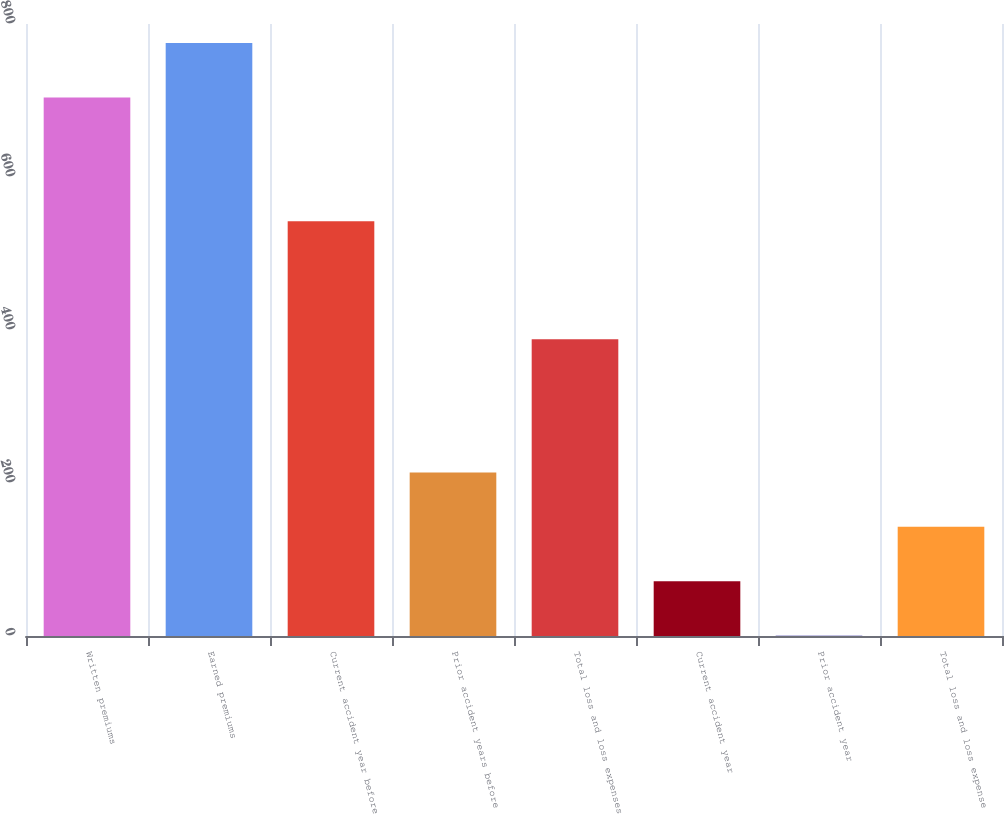Convert chart to OTSL. <chart><loc_0><loc_0><loc_500><loc_500><bar_chart><fcel>Written premiums<fcel>Earned premiums<fcel>Current accident year before<fcel>Prior accident years before<fcel>Total loss and loss expenses<fcel>Current accident year<fcel>Prior accident year<fcel>Total loss and loss expense<nl><fcel>704<fcel>775.16<fcel>542<fcel>213.86<fcel>388<fcel>71.54<fcel>0.38<fcel>142.7<nl></chart> 